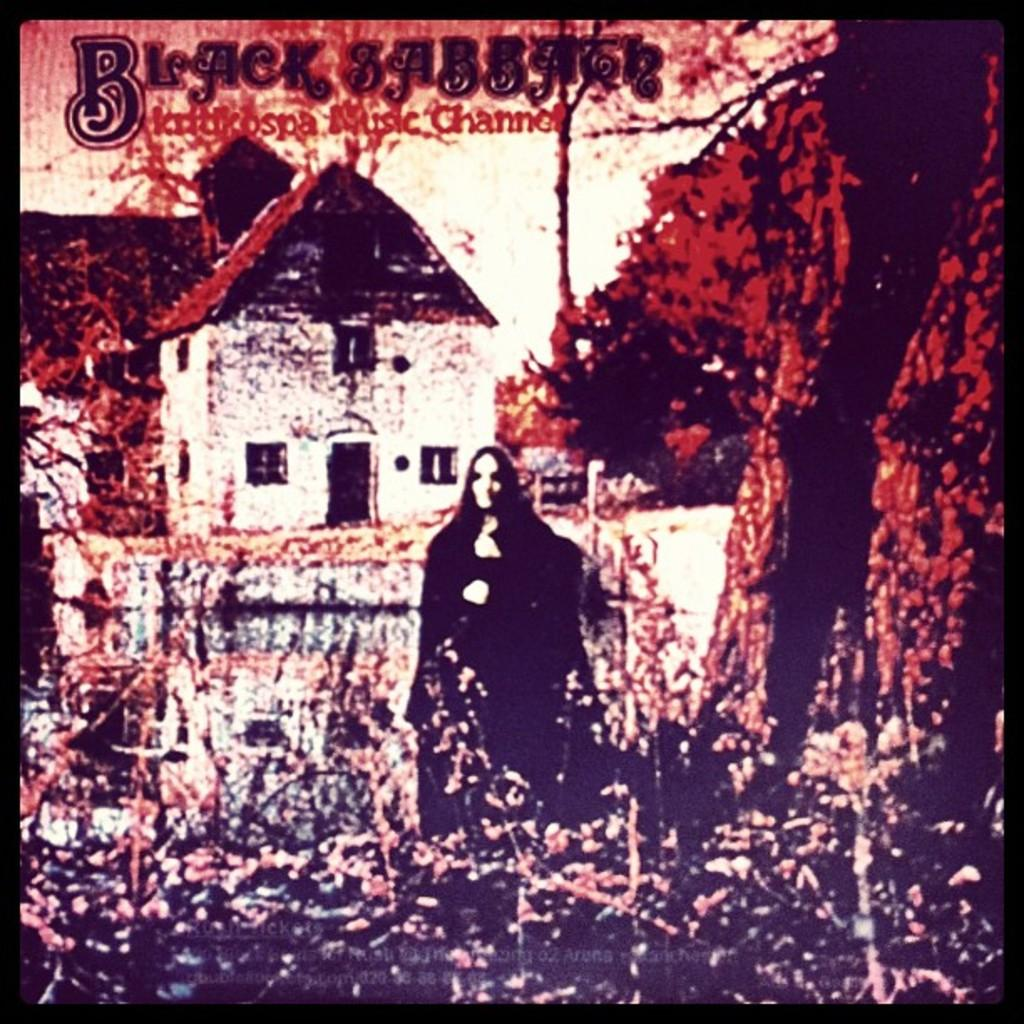What type of editing has been done to the image? The image is edited, but the specific type of editing is not mentioned in the facts. What structure can be seen in the image? There is a building in the image. What type of natural environment is visible in the image? There are trees in the image. What is the woman in the image doing? The woman is standing on the ground in the image. What is written at the top of the image? There is some text at the top of the image. What type of grass is growing around the woman in the image? There is no grass visible in the image; it only shows a building, trees, and a woman standing on the ground. Who is the manager of the building in the image? The facts do not mention any information about a manager or the building's ownership, so it cannot be determined from the image. 